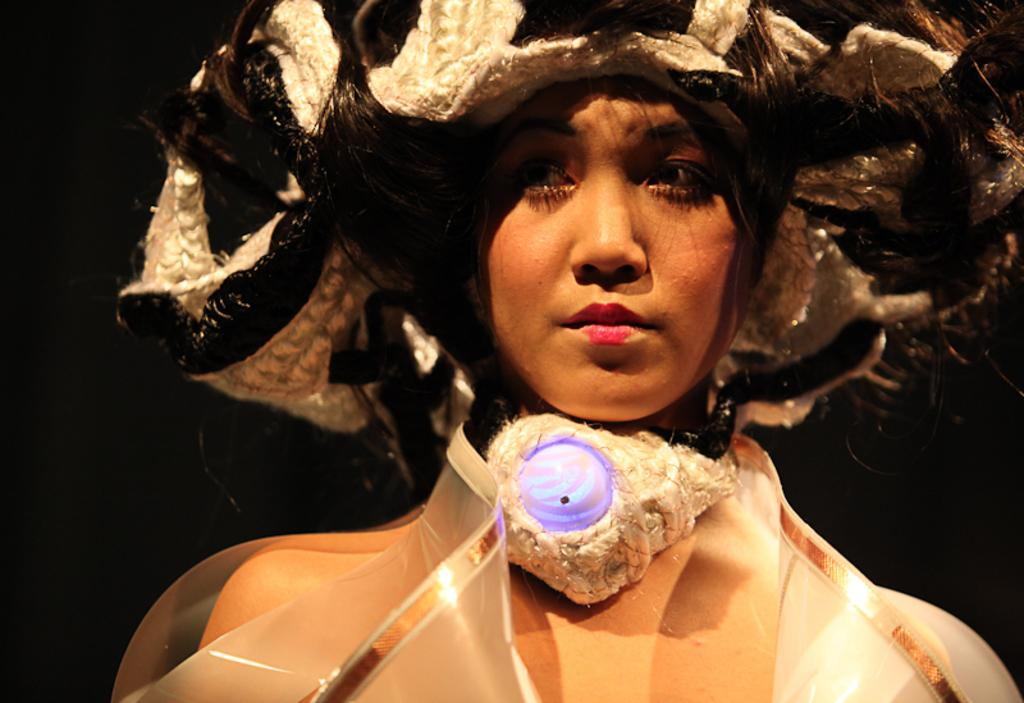Who is present in the image? There is a lady in the image. What is the lady wearing? The lady is wearing a costume. What type of building can be seen in the background of the image? There is no building present in the image; it only features a lady wearing a costume. 